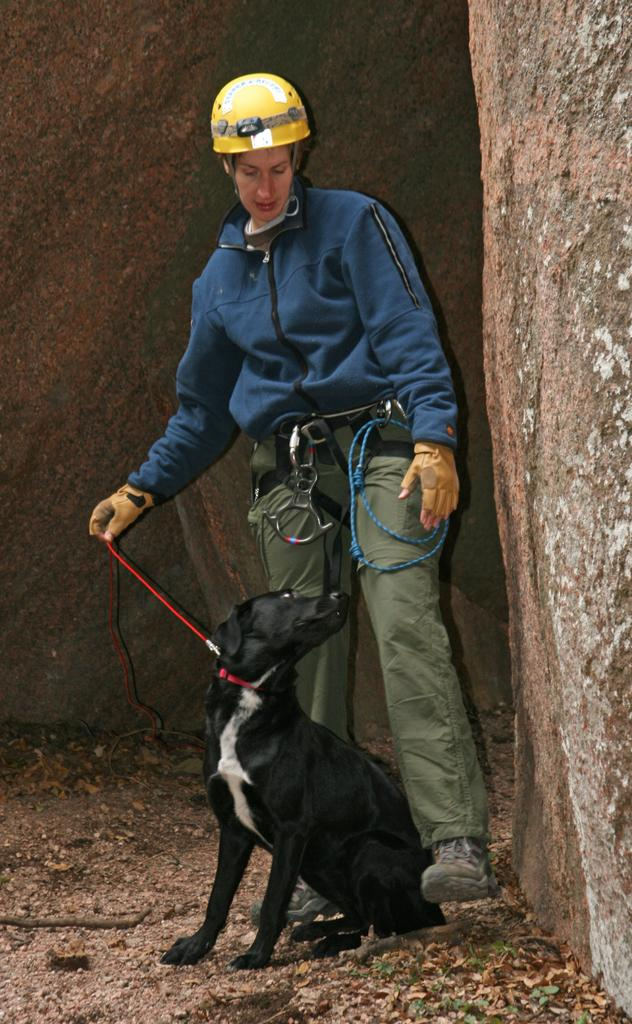What is present in the image along with the person? There is a dog in the image. What type of animal is in the image? The animal in the image is a dog. What can be seen in the background of the image? There are rocks in the background of the image. What type of drum can be seen in the image? There is no drum present in the image. Is there a beam visible in the image? There is no beam present in the image. Where is the library located in the image? There is no library present in the image. 